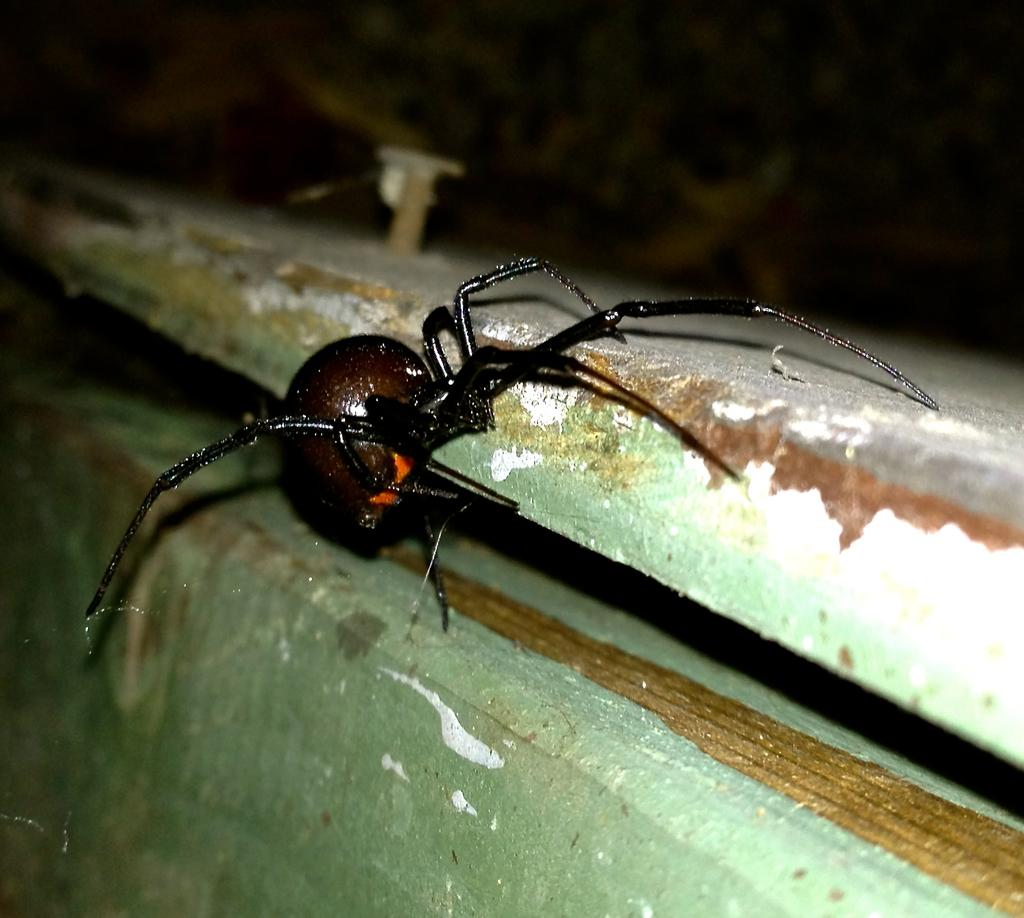What type of creature is in the image? There is an insect in the image. Can you describe the colors of the insect? The insect has brown, black, and orange colors. What is the insect resting on in the image? The insect is on a wooden surface. How would you describe the colors of the wooden surface? The wooden surface has green, brown, and white colors. What can be said about the background of the image? The background of the image is blurry. What type of honey is being produced by the insect in the image? There is no indication in the image that the insect is producing honey. 